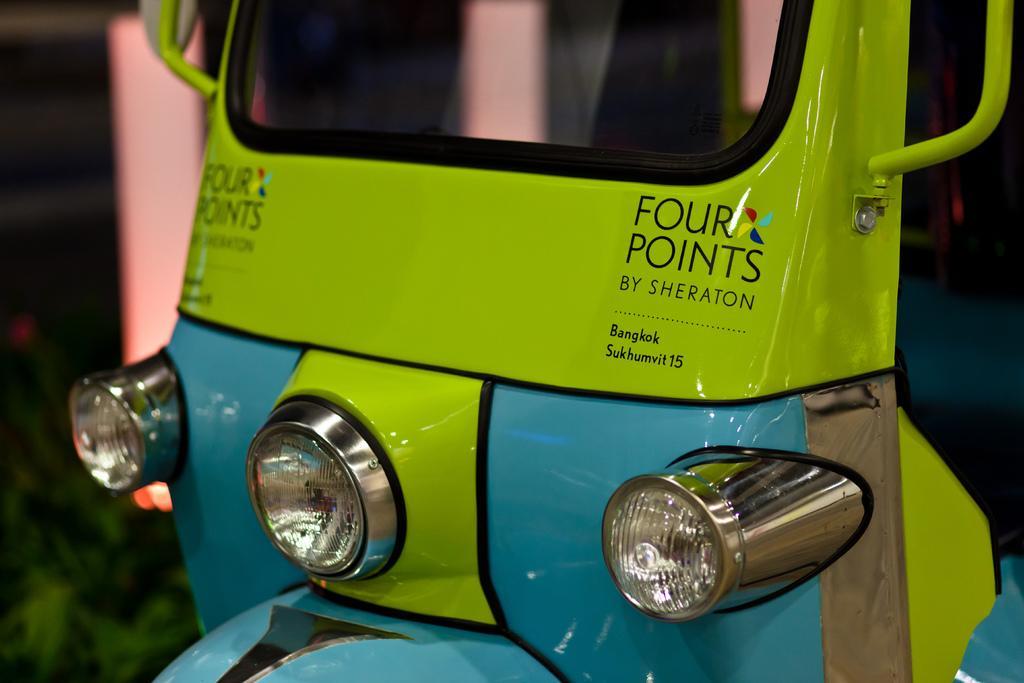Could you give a brief overview of what you see in this image? In the foreground I can see a auto rickshaw. This image is taken during night may be on the road. 